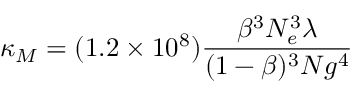<formula> <loc_0><loc_0><loc_500><loc_500>\kappa _ { M } = ( 1 . 2 \times 1 0 ^ { 8 } ) \frac { \beta ^ { 3 } N _ { e } ^ { 3 } \lambda } { ( 1 - \beta ) ^ { 3 } N g ^ { 4 } }</formula> 